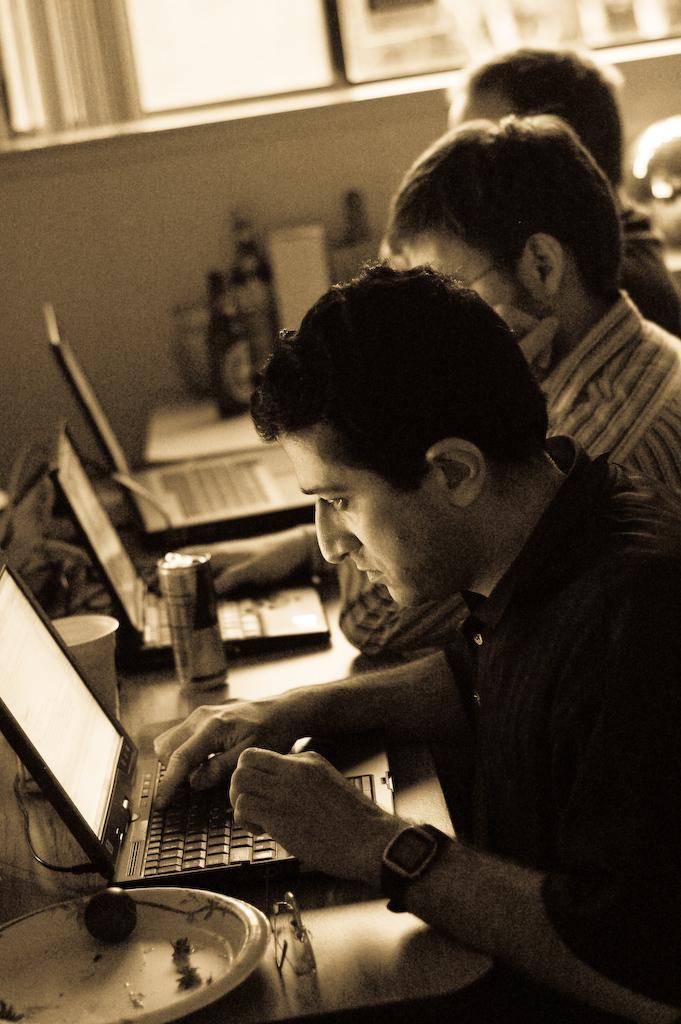Please provide a concise description of this image. In this picture we can see three people, in front of them we can see a platform, on the platform we can see laptops, bottles and some objects and in the background we can see some objects. 